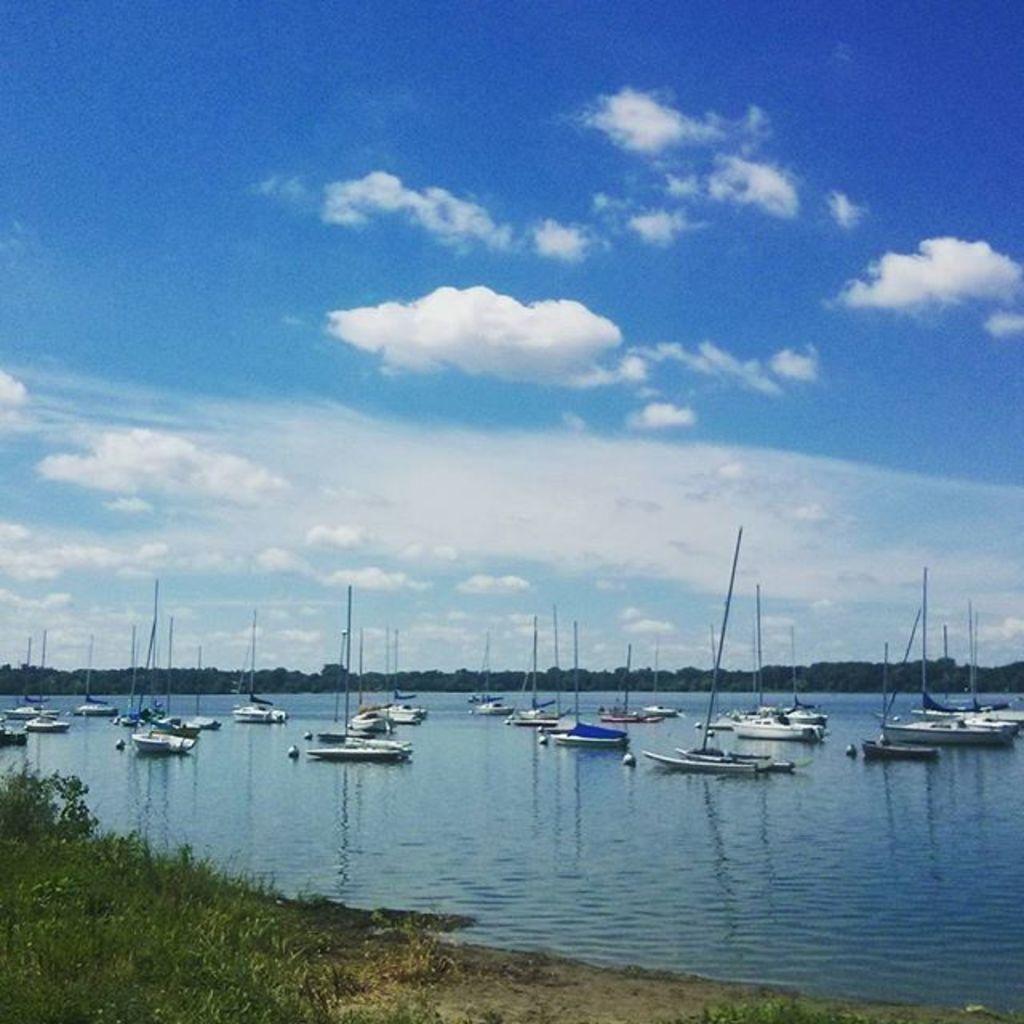Describe this image in one or two sentences. In this image I can see boats on the water. There are trees, there is grass and in the background there is sky. 